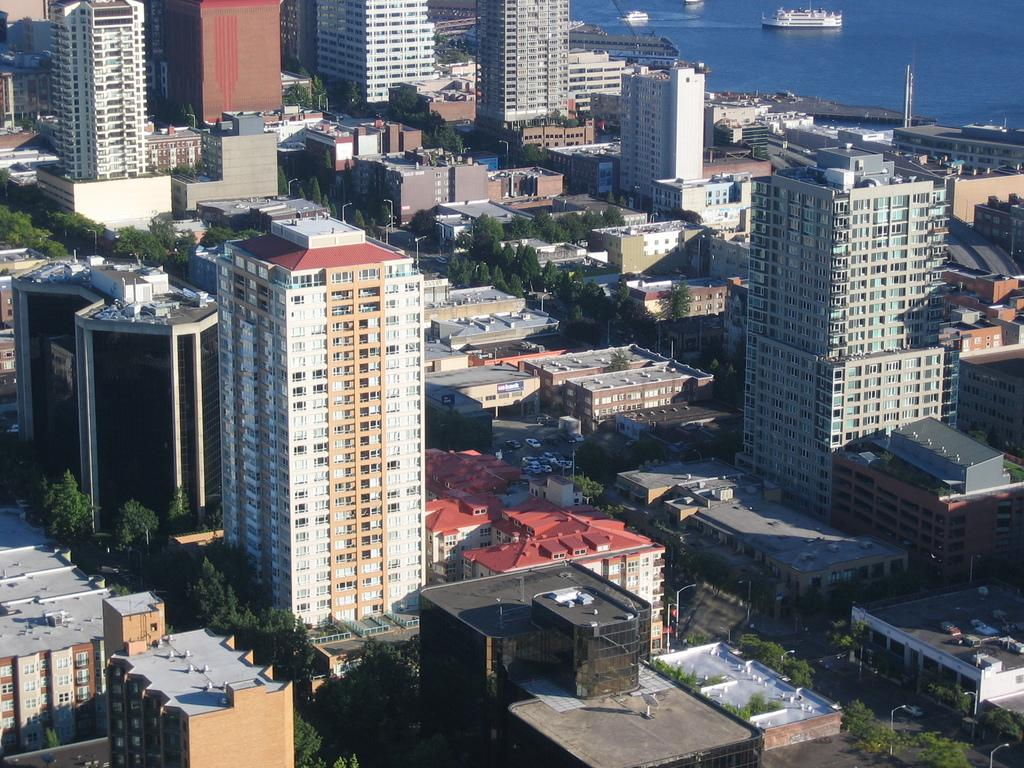What type of structures can be seen in the image? There are buildings in the image. What are the vertical objects in the image? There are poles and light poles in the image. What architectural features can be observed in the buildings? There are windows in the image. What type of vegetation is present in the image? There are trees in the image. What type of transportation is visible on the road? There are vehicles on the road in the image. What type of watercraft can be seen on the water surface? There are ships visible on the water surface in the image. What type of skirt is worn by the low-hanging clouds in the image? There are no clouds or skirts present in the image. How does one sort the vehicles on the road based on their color in the image? The image does not provide information about the colors of the vehicles, so it is not possible to sort them based on color. 